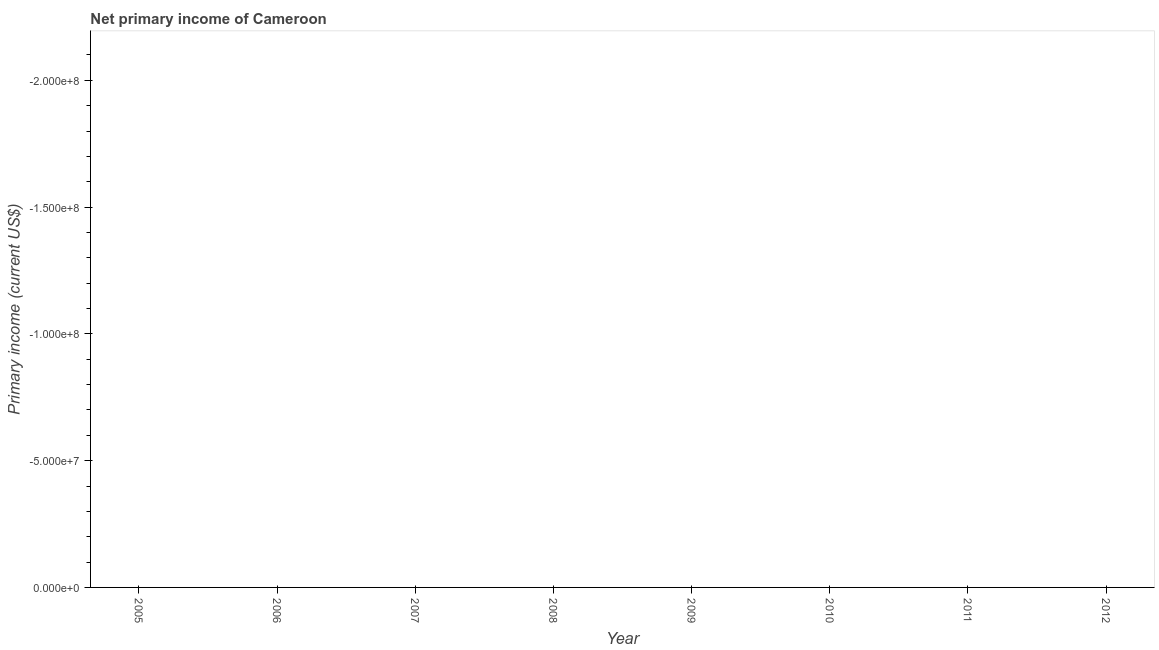Across all years, what is the minimum amount of primary income?
Offer a very short reply. 0. What is the median amount of primary income?
Provide a succinct answer. 0. Does the amount of primary income monotonically increase over the years?
Your answer should be compact. No. How many lines are there?
Your answer should be compact. 0. How many years are there in the graph?
Provide a short and direct response. 8. What is the difference between two consecutive major ticks on the Y-axis?
Your answer should be compact. 5.00e+07. Does the graph contain any zero values?
Your answer should be very brief. Yes. Does the graph contain grids?
Your response must be concise. No. What is the title of the graph?
Your answer should be very brief. Net primary income of Cameroon. What is the label or title of the Y-axis?
Your response must be concise. Primary income (current US$). What is the Primary income (current US$) of 2007?
Your answer should be compact. 0. What is the Primary income (current US$) of 2011?
Give a very brief answer. 0. What is the Primary income (current US$) of 2012?
Ensure brevity in your answer.  0. 